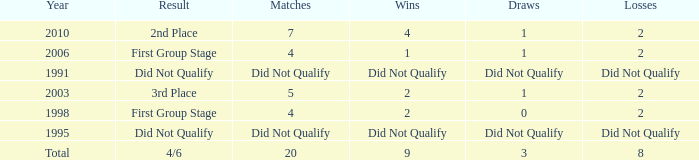Can you parse all the data within this table? {'header': ['Year', 'Result', 'Matches', 'Wins', 'Draws', 'Losses'], 'rows': [['2010', '2nd Place', '7', '4', '1', '2'], ['2006', 'First Group Stage', '4', '1', '1', '2'], ['1991', 'Did Not Qualify', 'Did Not Qualify', 'Did Not Qualify', 'Did Not Qualify', 'Did Not Qualify'], ['2003', '3rd Place', '5', '2', '1', '2'], ['1998', 'First Group Stage', '4', '2', '0', '2'], ['1995', 'Did Not Qualify', 'Did Not Qualify', 'Did Not Qualify', 'Did Not Qualify', 'Did Not Qualify'], ['Total', '4/6', '20', '9', '3', '8']]} What was the result for the team with 3 draws? 4/6. 